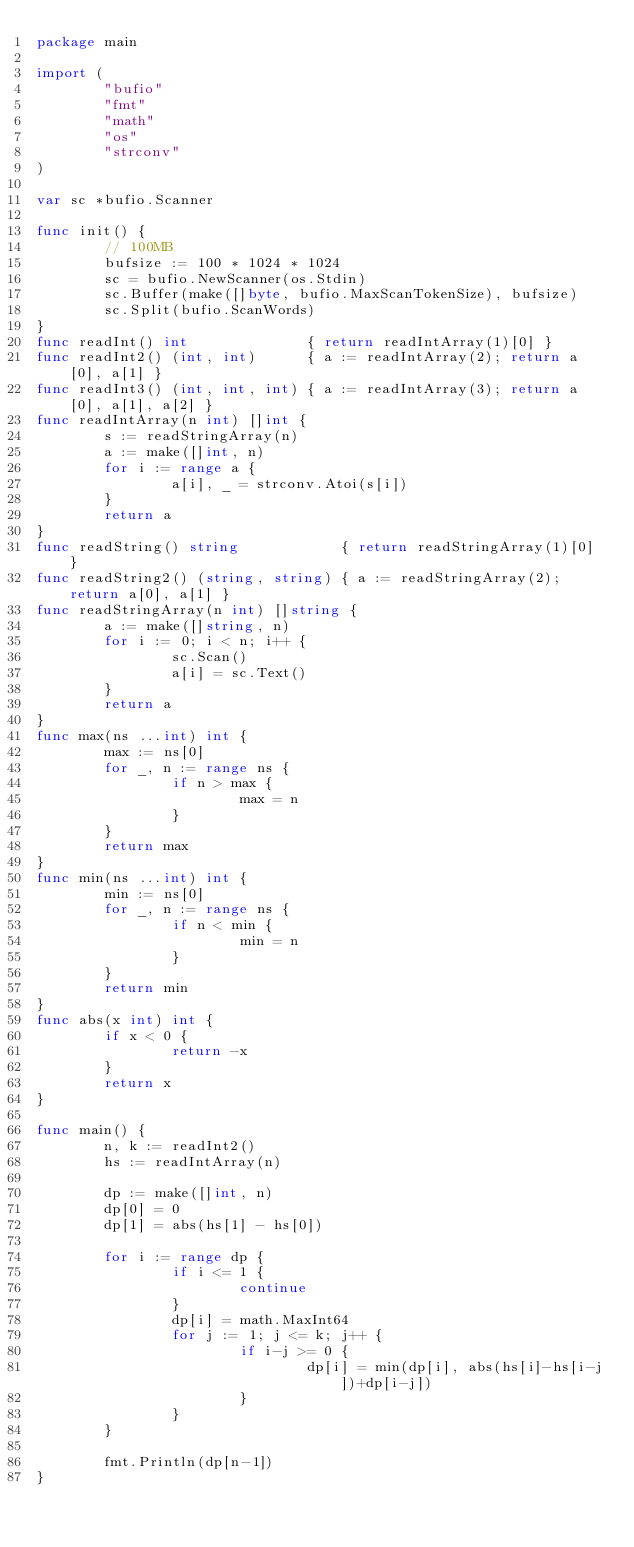<code> <loc_0><loc_0><loc_500><loc_500><_Go_>package main

import (
        "bufio"
        "fmt"
        "math"
        "os"
        "strconv"
)

var sc *bufio.Scanner

func init() {
        // 100MB
        bufsize := 100 * 1024 * 1024
        sc = bufio.NewScanner(os.Stdin)
        sc.Buffer(make([]byte, bufio.MaxScanTokenSize), bufsize)
        sc.Split(bufio.ScanWords)
}
func readInt() int              { return readIntArray(1)[0] }
func readInt2() (int, int)      { a := readIntArray(2); return a[0], a[1] }
func readInt3() (int, int, int) { a := readIntArray(3); return a[0], a[1], a[2] }
func readIntArray(n int) []int {
        s := readStringArray(n)
        a := make([]int, n)
        for i := range a {
                a[i], _ = strconv.Atoi(s[i])
        }
        return a
}
func readString() string            { return readStringArray(1)[0] }
func readString2() (string, string) { a := readStringArray(2); return a[0], a[1] }
func readStringArray(n int) []string {
        a := make([]string, n)
        for i := 0; i < n; i++ {
                sc.Scan()
                a[i] = sc.Text()
        }
        return a
}
func max(ns ...int) int {
        max := ns[0]
        for _, n := range ns {
                if n > max {
                        max = n
                }
        }
        return max
}
func min(ns ...int) int {
        min := ns[0]
        for _, n := range ns {
                if n < min {
                        min = n
                }
        }
        return min
}
func abs(x int) int {
        if x < 0 {
                return -x
        }
        return x
}

func main() {
        n, k := readInt2()
        hs := readIntArray(n)

        dp := make([]int, n)
        dp[0] = 0
        dp[1] = abs(hs[1] - hs[0])

        for i := range dp {
                if i <= 1 {
                        continue
                }
                dp[i] = math.MaxInt64
                for j := 1; j <= k; j++ {
                        if i-j >= 0 {
                                dp[i] = min(dp[i], abs(hs[i]-hs[i-j])+dp[i-j])
                        }
                }
        }

        fmt.Println(dp[n-1])
}</code> 